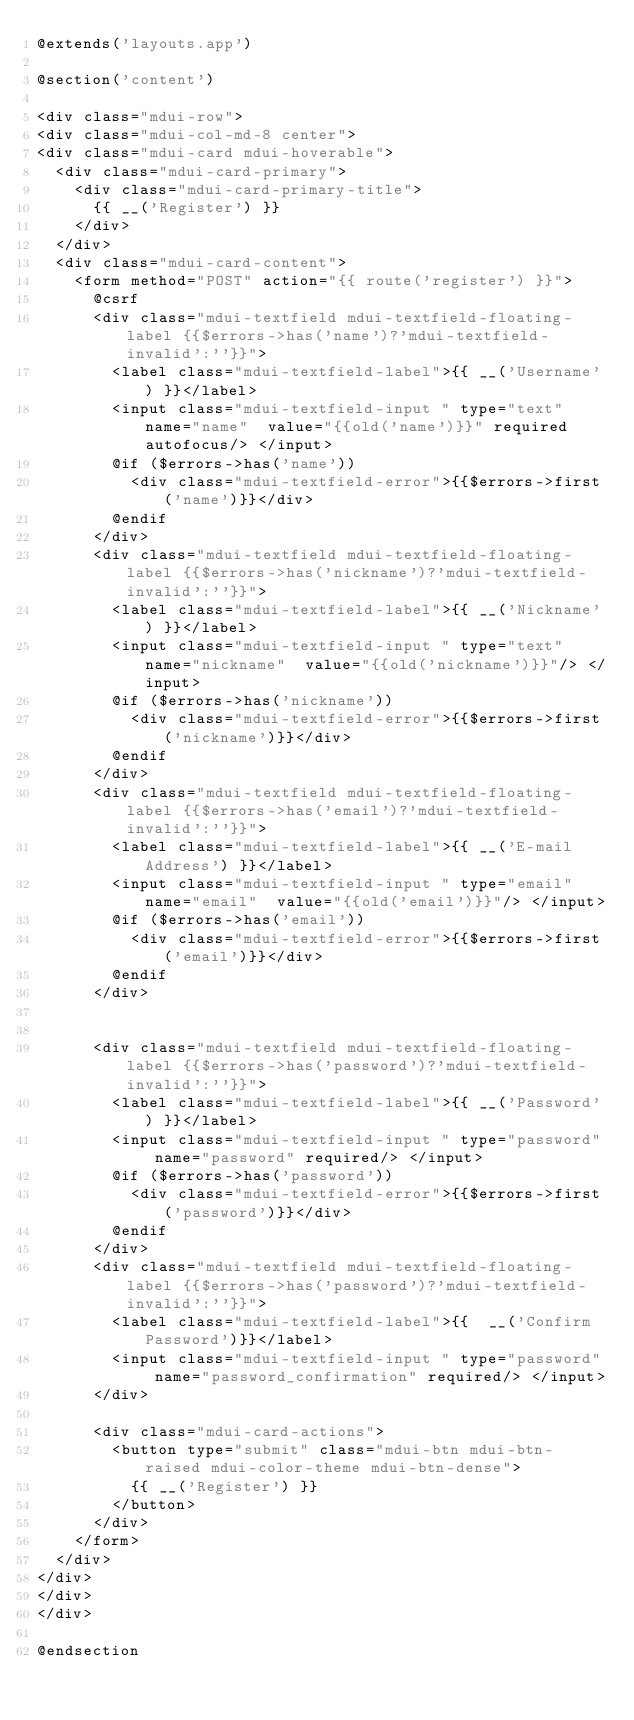Convert code to text. <code><loc_0><loc_0><loc_500><loc_500><_PHP_>@extends('layouts.app')

@section('content')

<div class="mdui-row">
<div class="mdui-col-md-8 center">
<div class="mdui-card mdui-hoverable">
	<div class="mdui-card-primary">
		<div class="mdui-card-primary-title">
			{{ __('Register') }}
		</div>
	</div>
	<div class="mdui-card-content">
		<form method="POST" action="{{ route('register') }}">
			@csrf
			<div class="mdui-textfield mdui-textfield-floating-label {{$errors->has('name')?'mdui-textfield-invalid':''}}">
				<label class="mdui-textfield-label">{{ __('Username') }}</label>
				<input class="mdui-textfield-input " type="text" name="name"  value="{{old('name')}}" required autofocus/> </input>
				@if ($errors->has('name'))
					<div class="mdui-textfield-error">{{$errors->first('name')}}</div>	
				@endif
			</div>
			<div class="mdui-textfield mdui-textfield-floating-label {{$errors->has('nickname')?'mdui-textfield-invalid':''}}">
				<label class="mdui-textfield-label">{{ __('Nickname') }}</label>
				<input class="mdui-textfield-input " type="text" name="nickname"  value="{{old('nickname')}}"/> </input>
				@if ($errors->has('nickname'))
					<div class="mdui-textfield-error">{{$errors->first('nickname')}}</div>	
				@endif
			</div>
			<div class="mdui-textfield mdui-textfield-floating-label {{$errors->has('email')?'mdui-textfield-invalid':''}}">
				<label class="mdui-textfield-label">{{ __('E-mail Address') }}</label>
				<input class="mdui-textfield-input " type="email" name="email"  value="{{old('email')}}"/> </input>
				@if ($errors->has('email'))
					<div class="mdui-textfield-error">{{$errors->first('email')}}</div>	
				@endif
			</div>


			<div class="mdui-textfield mdui-textfield-floating-label {{$errors->has('password')?'mdui-textfield-invalid':''}}">
				<label class="mdui-textfield-label">{{ __('Password') }}</label>
				<input class="mdui-textfield-input " type="password" name="password" required/> </input>
				@if ($errors->has('password'))
					<div class="mdui-textfield-error">{{$errors->first('password')}}</div>	
				@endif
			</div>
			<div class="mdui-textfield mdui-textfield-floating-label {{$errors->has('password')?'mdui-textfield-invalid':''}}">
				<label class="mdui-textfield-label">{{  __('Confirm Password')}}</label>
				<input class="mdui-textfield-input " type="password" name="password_confirmation" required/> </input>
			</div>

			<div class="mdui-card-actions">
				<button type="submit" class="mdui-btn mdui-btn-raised mdui-color-theme mdui-btn-dense">
					{{ __('Register') }}
				</button>
			</div>
		</form>
	</div>
</div>
</div>
</div>

@endsection
</code> 